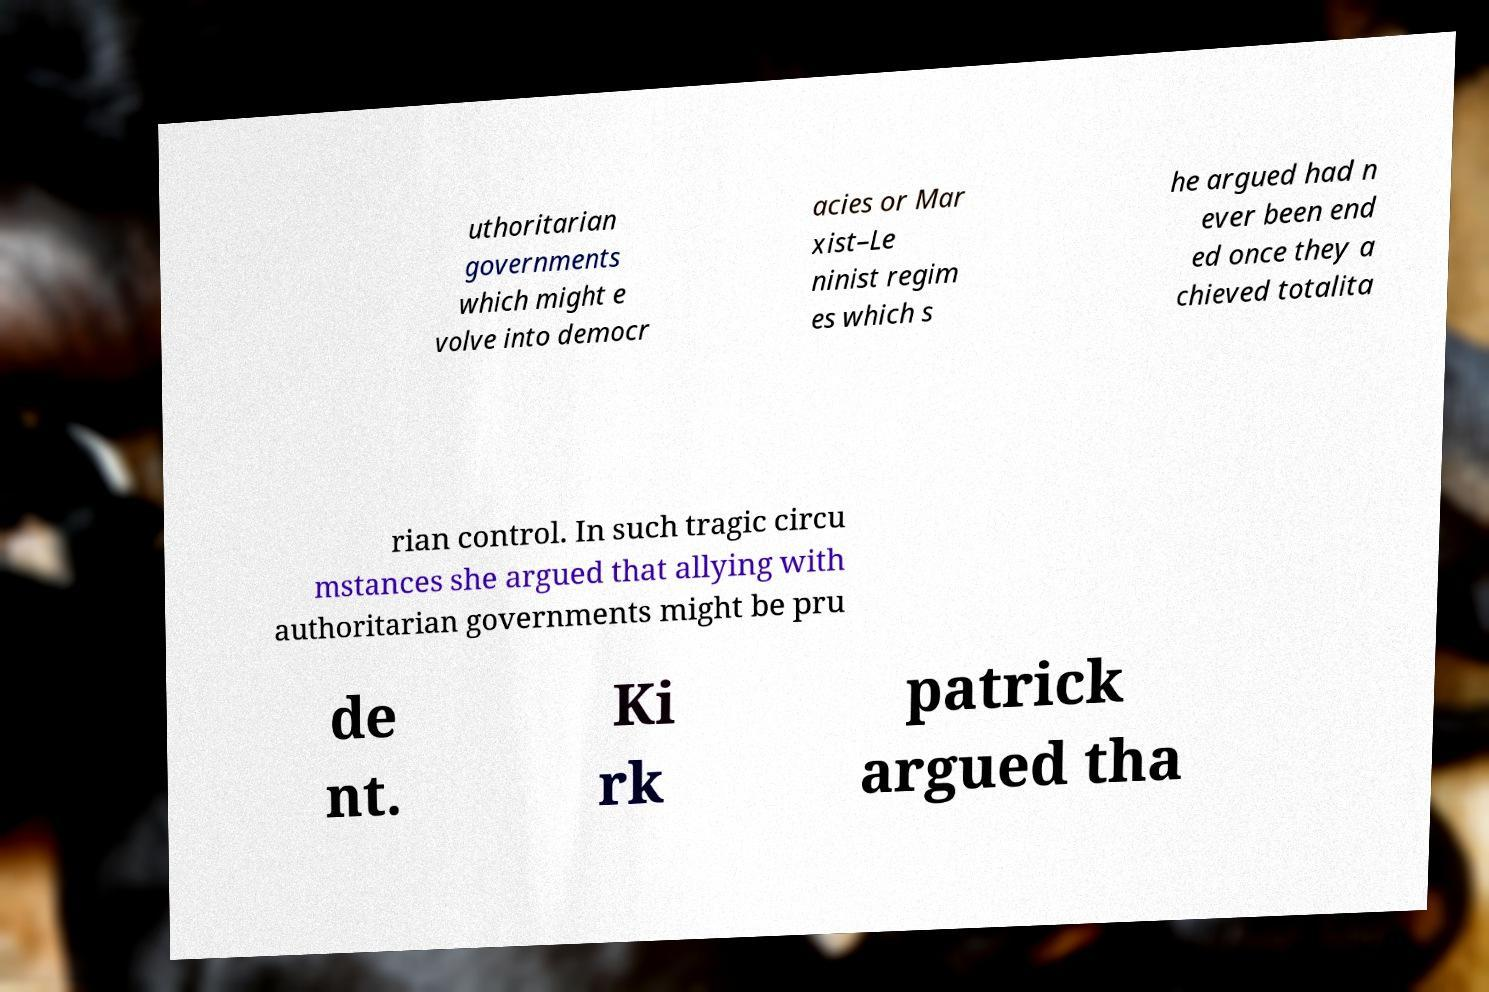There's text embedded in this image that I need extracted. Can you transcribe it verbatim? uthoritarian governments which might e volve into democr acies or Mar xist–Le ninist regim es which s he argued had n ever been end ed once they a chieved totalita rian control. In such tragic circu mstances she argued that allying with authoritarian governments might be pru de nt. Ki rk patrick argued tha 